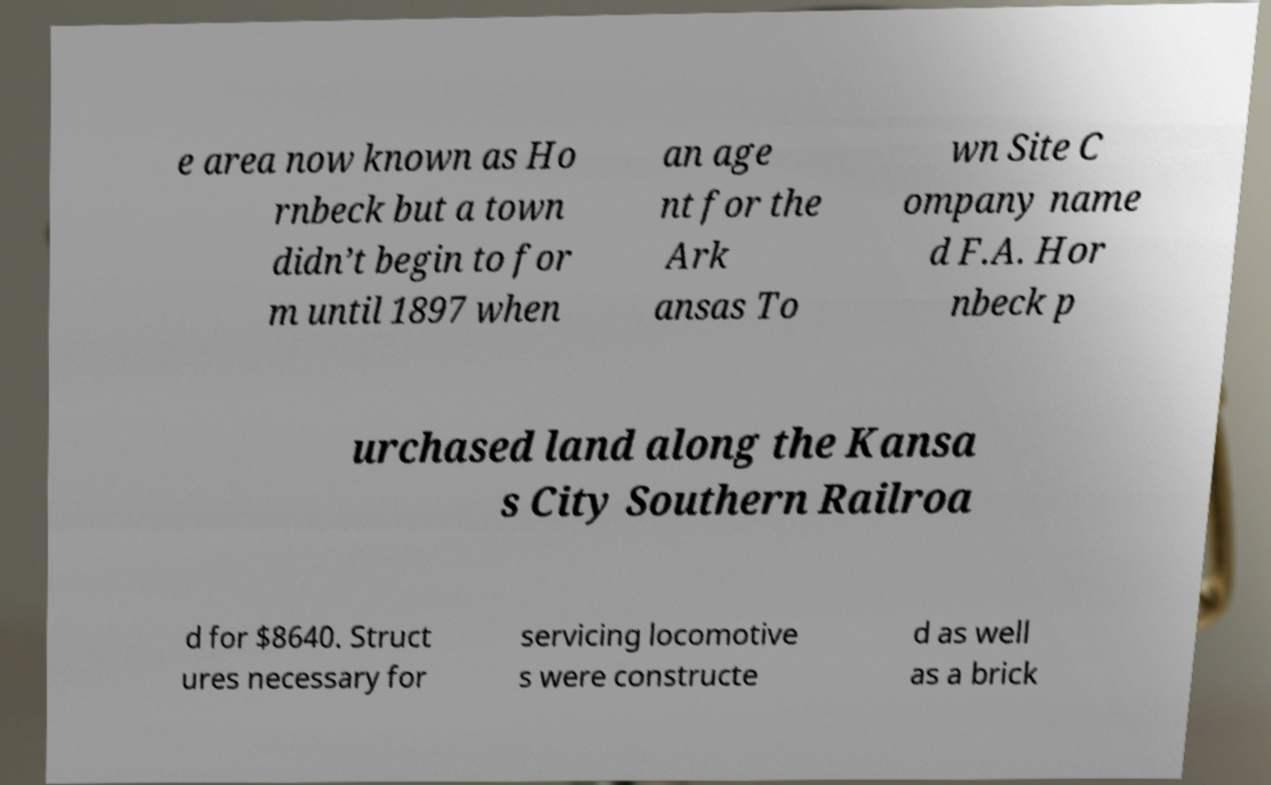There's text embedded in this image that I need extracted. Can you transcribe it verbatim? e area now known as Ho rnbeck but a town didn’t begin to for m until 1897 when an age nt for the Ark ansas To wn Site C ompany name d F.A. Hor nbeck p urchased land along the Kansa s City Southern Railroa d for $8640. Struct ures necessary for servicing locomotive s were constructe d as well as a brick 